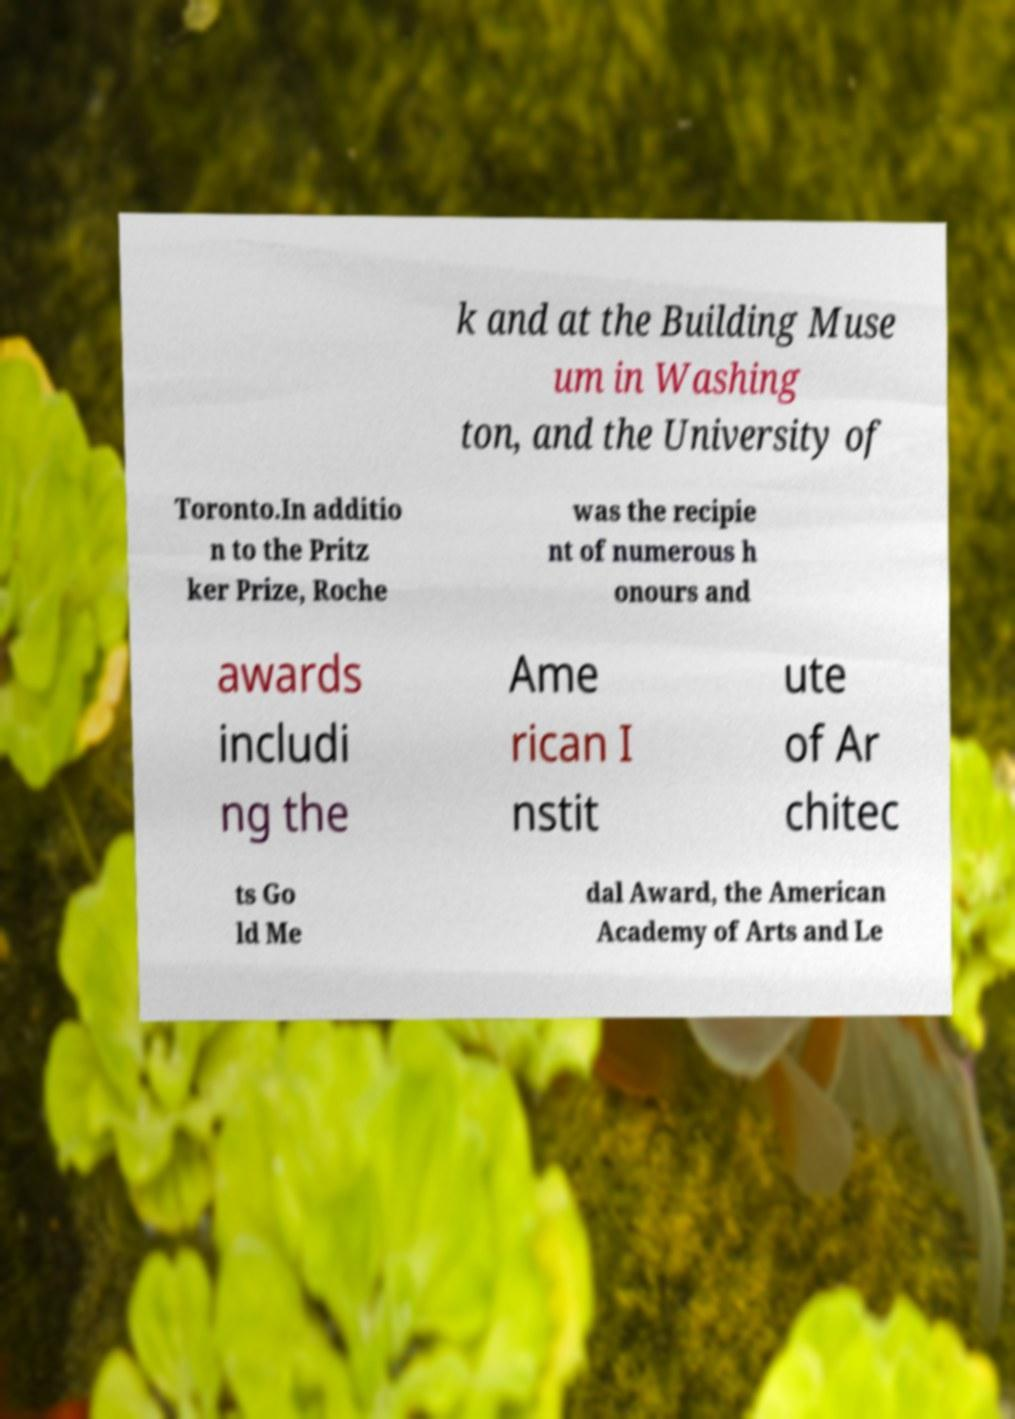What messages or text are displayed in this image? I need them in a readable, typed format. k and at the Building Muse um in Washing ton, and the University of Toronto.In additio n to the Pritz ker Prize, Roche was the recipie nt of numerous h onours and awards includi ng the Ame rican I nstit ute of Ar chitec ts Go ld Me dal Award, the American Academy of Arts and Le 